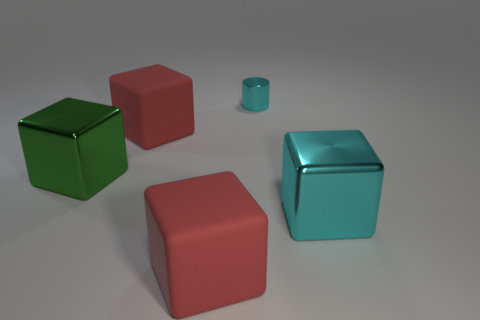What is the color of the other big shiny object that is the same shape as the big green shiny thing?
Offer a terse response. Cyan. How many metallic objects are the same color as the cylinder?
Your answer should be very brief. 1. Does the green cube have the same size as the cyan shiny cylinder?
Provide a succinct answer. No. What is the small cylinder made of?
Provide a short and direct response. Metal. There is a tiny object that is the same material as the big cyan cube; what color is it?
Your response must be concise. Cyan. Are the big green block and the red cube behind the big cyan thing made of the same material?
Your answer should be compact. No. How many large yellow cylinders are the same material as the tiny cylinder?
Ensure brevity in your answer.  0. There is a red object behind the green block; what is its shape?
Your response must be concise. Cube. Are the red block that is in front of the green shiny object and the big object that is on the right side of the tiny shiny object made of the same material?
Keep it short and to the point. No. Are there any other green metallic objects of the same shape as the small object?
Give a very brief answer. No. 